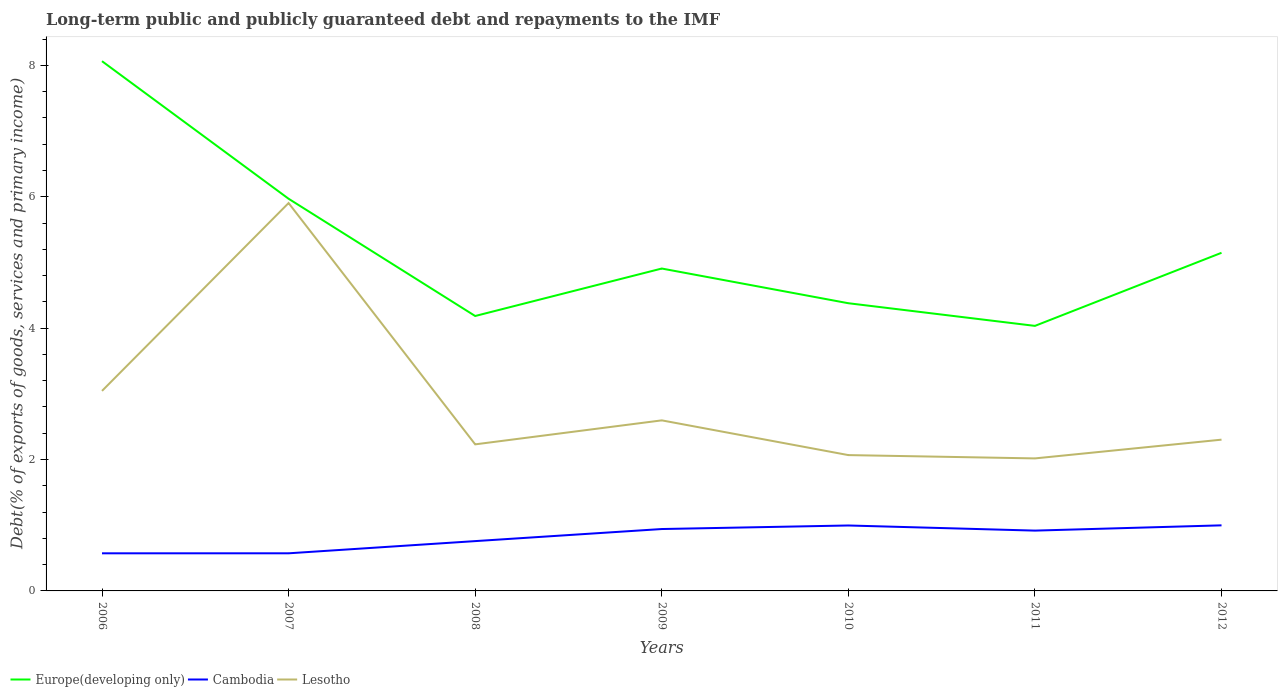Does the line corresponding to Cambodia intersect with the line corresponding to Lesotho?
Ensure brevity in your answer.  No. Is the number of lines equal to the number of legend labels?
Your answer should be compact. Yes. Across all years, what is the maximum debt and repayments in Europe(developing only)?
Give a very brief answer. 4.03. In which year was the debt and repayments in Europe(developing only) maximum?
Your response must be concise. 2011. What is the total debt and repayments in Cambodia in the graph?
Your answer should be very brief. -0.19. What is the difference between the highest and the second highest debt and repayments in Cambodia?
Offer a very short reply. 0.43. Is the debt and repayments in Lesotho strictly greater than the debt and repayments in Europe(developing only) over the years?
Ensure brevity in your answer.  Yes. How many years are there in the graph?
Offer a very short reply. 7. What is the difference between two consecutive major ticks on the Y-axis?
Your answer should be compact. 2. Does the graph contain grids?
Your answer should be very brief. No. Where does the legend appear in the graph?
Ensure brevity in your answer.  Bottom left. How are the legend labels stacked?
Your response must be concise. Horizontal. What is the title of the graph?
Give a very brief answer. Long-term public and publicly guaranteed debt and repayments to the IMF. What is the label or title of the X-axis?
Offer a terse response. Years. What is the label or title of the Y-axis?
Ensure brevity in your answer.  Debt(% of exports of goods, services and primary income). What is the Debt(% of exports of goods, services and primary income) in Europe(developing only) in 2006?
Ensure brevity in your answer.  8.06. What is the Debt(% of exports of goods, services and primary income) of Cambodia in 2006?
Give a very brief answer. 0.57. What is the Debt(% of exports of goods, services and primary income) of Lesotho in 2006?
Offer a terse response. 3.04. What is the Debt(% of exports of goods, services and primary income) in Europe(developing only) in 2007?
Your answer should be very brief. 5.97. What is the Debt(% of exports of goods, services and primary income) of Cambodia in 2007?
Ensure brevity in your answer.  0.57. What is the Debt(% of exports of goods, services and primary income) in Lesotho in 2007?
Your response must be concise. 5.9. What is the Debt(% of exports of goods, services and primary income) in Europe(developing only) in 2008?
Provide a succinct answer. 4.18. What is the Debt(% of exports of goods, services and primary income) in Cambodia in 2008?
Keep it short and to the point. 0.76. What is the Debt(% of exports of goods, services and primary income) in Lesotho in 2008?
Your answer should be compact. 2.23. What is the Debt(% of exports of goods, services and primary income) in Europe(developing only) in 2009?
Give a very brief answer. 4.91. What is the Debt(% of exports of goods, services and primary income) in Cambodia in 2009?
Ensure brevity in your answer.  0.94. What is the Debt(% of exports of goods, services and primary income) of Lesotho in 2009?
Your answer should be very brief. 2.6. What is the Debt(% of exports of goods, services and primary income) in Europe(developing only) in 2010?
Your response must be concise. 4.38. What is the Debt(% of exports of goods, services and primary income) of Cambodia in 2010?
Your answer should be very brief. 1. What is the Debt(% of exports of goods, services and primary income) of Lesotho in 2010?
Your answer should be very brief. 2.07. What is the Debt(% of exports of goods, services and primary income) of Europe(developing only) in 2011?
Your answer should be compact. 4.03. What is the Debt(% of exports of goods, services and primary income) in Cambodia in 2011?
Provide a short and direct response. 0.92. What is the Debt(% of exports of goods, services and primary income) in Lesotho in 2011?
Keep it short and to the point. 2.02. What is the Debt(% of exports of goods, services and primary income) in Europe(developing only) in 2012?
Give a very brief answer. 5.15. What is the Debt(% of exports of goods, services and primary income) of Cambodia in 2012?
Your answer should be very brief. 1. What is the Debt(% of exports of goods, services and primary income) in Lesotho in 2012?
Make the answer very short. 2.3. Across all years, what is the maximum Debt(% of exports of goods, services and primary income) in Europe(developing only)?
Provide a succinct answer. 8.06. Across all years, what is the maximum Debt(% of exports of goods, services and primary income) of Cambodia?
Keep it short and to the point. 1. Across all years, what is the maximum Debt(% of exports of goods, services and primary income) in Lesotho?
Your answer should be very brief. 5.9. Across all years, what is the minimum Debt(% of exports of goods, services and primary income) in Europe(developing only)?
Offer a terse response. 4.03. Across all years, what is the minimum Debt(% of exports of goods, services and primary income) of Cambodia?
Provide a succinct answer. 0.57. Across all years, what is the minimum Debt(% of exports of goods, services and primary income) in Lesotho?
Provide a succinct answer. 2.02. What is the total Debt(% of exports of goods, services and primary income) in Europe(developing only) in the graph?
Your answer should be very brief. 36.69. What is the total Debt(% of exports of goods, services and primary income) in Cambodia in the graph?
Provide a succinct answer. 5.76. What is the total Debt(% of exports of goods, services and primary income) of Lesotho in the graph?
Offer a terse response. 20.16. What is the difference between the Debt(% of exports of goods, services and primary income) of Europe(developing only) in 2006 and that in 2007?
Ensure brevity in your answer.  2.09. What is the difference between the Debt(% of exports of goods, services and primary income) of Cambodia in 2006 and that in 2007?
Make the answer very short. -0. What is the difference between the Debt(% of exports of goods, services and primary income) of Lesotho in 2006 and that in 2007?
Your response must be concise. -2.86. What is the difference between the Debt(% of exports of goods, services and primary income) in Europe(developing only) in 2006 and that in 2008?
Ensure brevity in your answer.  3.88. What is the difference between the Debt(% of exports of goods, services and primary income) in Cambodia in 2006 and that in 2008?
Offer a very short reply. -0.19. What is the difference between the Debt(% of exports of goods, services and primary income) in Lesotho in 2006 and that in 2008?
Offer a terse response. 0.81. What is the difference between the Debt(% of exports of goods, services and primary income) of Europe(developing only) in 2006 and that in 2009?
Your answer should be very brief. 3.16. What is the difference between the Debt(% of exports of goods, services and primary income) of Cambodia in 2006 and that in 2009?
Provide a succinct answer. -0.37. What is the difference between the Debt(% of exports of goods, services and primary income) in Lesotho in 2006 and that in 2009?
Your response must be concise. 0.45. What is the difference between the Debt(% of exports of goods, services and primary income) in Europe(developing only) in 2006 and that in 2010?
Ensure brevity in your answer.  3.68. What is the difference between the Debt(% of exports of goods, services and primary income) of Cambodia in 2006 and that in 2010?
Give a very brief answer. -0.42. What is the difference between the Debt(% of exports of goods, services and primary income) of Lesotho in 2006 and that in 2010?
Ensure brevity in your answer.  0.98. What is the difference between the Debt(% of exports of goods, services and primary income) of Europe(developing only) in 2006 and that in 2011?
Your response must be concise. 4.03. What is the difference between the Debt(% of exports of goods, services and primary income) of Cambodia in 2006 and that in 2011?
Provide a short and direct response. -0.35. What is the difference between the Debt(% of exports of goods, services and primary income) of Lesotho in 2006 and that in 2011?
Offer a very short reply. 1.03. What is the difference between the Debt(% of exports of goods, services and primary income) in Europe(developing only) in 2006 and that in 2012?
Ensure brevity in your answer.  2.92. What is the difference between the Debt(% of exports of goods, services and primary income) of Cambodia in 2006 and that in 2012?
Give a very brief answer. -0.43. What is the difference between the Debt(% of exports of goods, services and primary income) of Lesotho in 2006 and that in 2012?
Ensure brevity in your answer.  0.74. What is the difference between the Debt(% of exports of goods, services and primary income) of Europe(developing only) in 2007 and that in 2008?
Your answer should be compact. 1.78. What is the difference between the Debt(% of exports of goods, services and primary income) in Cambodia in 2007 and that in 2008?
Give a very brief answer. -0.19. What is the difference between the Debt(% of exports of goods, services and primary income) of Lesotho in 2007 and that in 2008?
Give a very brief answer. 3.67. What is the difference between the Debt(% of exports of goods, services and primary income) of Europe(developing only) in 2007 and that in 2009?
Offer a terse response. 1.06. What is the difference between the Debt(% of exports of goods, services and primary income) in Cambodia in 2007 and that in 2009?
Offer a very short reply. -0.37. What is the difference between the Debt(% of exports of goods, services and primary income) in Lesotho in 2007 and that in 2009?
Keep it short and to the point. 3.31. What is the difference between the Debt(% of exports of goods, services and primary income) of Europe(developing only) in 2007 and that in 2010?
Offer a very short reply. 1.59. What is the difference between the Debt(% of exports of goods, services and primary income) in Cambodia in 2007 and that in 2010?
Give a very brief answer. -0.42. What is the difference between the Debt(% of exports of goods, services and primary income) of Lesotho in 2007 and that in 2010?
Make the answer very short. 3.84. What is the difference between the Debt(% of exports of goods, services and primary income) in Europe(developing only) in 2007 and that in 2011?
Provide a succinct answer. 1.94. What is the difference between the Debt(% of exports of goods, services and primary income) in Cambodia in 2007 and that in 2011?
Your answer should be compact. -0.35. What is the difference between the Debt(% of exports of goods, services and primary income) in Lesotho in 2007 and that in 2011?
Offer a terse response. 3.89. What is the difference between the Debt(% of exports of goods, services and primary income) in Europe(developing only) in 2007 and that in 2012?
Your response must be concise. 0.82. What is the difference between the Debt(% of exports of goods, services and primary income) of Cambodia in 2007 and that in 2012?
Your answer should be compact. -0.43. What is the difference between the Debt(% of exports of goods, services and primary income) in Lesotho in 2007 and that in 2012?
Ensure brevity in your answer.  3.6. What is the difference between the Debt(% of exports of goods, services and primary income) of Europe(developing only) in 2008 and that in 2009?
Ensure brevity in your answer.  -0.72. What is the difference between the Debt(% of exports of goods, services and primary income) in Cambodia in 2008 and that in 2009?
Keep it short and to the point. -0.18. What is the difference between the Debt(% of exports of goods, services and primary income) of Lesotho in 2008 and that in 2009?
Your answer should be compact. -0.37. What is the difference between the Debt(% of exports of goods, services and primary income) of Europe(developing only) in 2008 and that in 2010?
Your answer should be compact. -0.19. What is the difference between the Debt(% of exports of goods, services and primary income) in Cambodia in 2008 and that in 2010?
Your answer should be very brief. -0.24. What is the difference between the Debt(% of exports of goods, services and primary income) of Lesotho in 2008 and that in 2010?
Make the answer very short. 0.16. What is the difference between the Debt(% of exports of goods, services and primary income) of Europe(developing only) in 2008 and that in 2011?
Your answer should be compact. 0.15. What is the difference between the Debt(% of exports of goods, services and primary income) in Cambodia in 2008 and that in 2011?
Ensure brevity in your answer.  -0.16. What is the difference between the Debt(% of exports of goods, services and primary income) in Lesotho in 2008 and that in 2011?
Provide a short and direct response. 0.21. What is the difference between the Debt(% of exports of goods, services and primary income) of Europe(developing only) in 2008 and that in 2012?
Give a very brief answer. -0.96. What is the difference between the Debt(% of exports of goods, services and primary income) in Cambodia in 2008 and that in 2012?
Your answer should be compact. -0.24. What is the difference between the Debt(% of exports of goods, services and primary income) of Lesotho in 2008 and that in 2012?
Your response must be concise. -0.07. What is the difference between the Debt(% of exports of goods, services and primary income) of Europe(developing only) in 2009 and that in 2010?
Keep it short and to the point. 0.53. What is the difference between the Debt(% of exports of goods, services and primary income) in Cambodia in 2009 and that in 2010?
Your response must be concise. -0.05. What is the difference between the Debt(% of exports of goods, services and primary income) in Lesotho in 2009 and that in 2010?
Make the answer very short. 0.53. What is the difference between the Debt(% of exports of goods, services and primary income) in Europe(developing only) in 2009 and that in 2011?
Provide a short and direct response. 0.87. What is the difference between the Debt(% of exports of goods, services and primary income) in Cambodia in 2009 and that in 2011?
Offer a very short reply. 0.02. What is the difference between the Debt(% of exports of goods, services and primary income) of Lesotho in 2009 and that in 2011?
Provide a succinct answer. 0.58. What is the difference between the Debt(% of exports of goods, services and primary income) in Europe(developing only) in 2009 and that in 2012?
Provide a short and direct response. -0.24. What is the difference between the Debt(% of exports of goods, services and primary income) of Cambodia in 2009 and that in 2012?
Your answer should be compact. -0.06. What is the difference between the Debt(% of exports of goods, services and primary income) in Lesotho in 2009 and that in 2012?
Make the answer very short. 0.29. What is the difference between the Debt(% of exports of goods, services and primary income) of Europe(developing only) in 2010 and that in 2011?
Offer a terse response. 0.34. What is the difference between the Debt(% of exports of goods, services and primary income) in Cambodia in 2010 and that in 2011?
Your answer should be compact. 0.08. What is the difference between the Debt(% of exports of goods, services and primary income) in Lesotho in 2010 and that in 2011?
Offer a very short reply. 0.05. What is the difference between the Debt(% of exports of goods, services and primary income) in Europe(developing only) in 2010 and that in 2012?
Offer a very short reply. -0.77. What is the difference between the Debt(% of exports of goods, services and primary income) of Cambodia in 2010 and that in 2012?
Make the answer very short. -0. What is the difference between the Debt(% of exports of goods, services and primary income) of Lesotho in 2010 and that in 2012?
Make the answer very short. -0.23. What is the difference between the Debt(% of exports of goods, services and primary income) of Europe(developing only) in 2011 and that in 2012?
Provide a succinct answer. -1.11. What is the difference between the Debt(% of exports of goods, services and primary income) in Cambodia in 2011 and that in 2012?
Ensure brevity in your answer.  -0.08. What is the difference between the Debt(% of exports of goods, services and primary income) of Lesotho in 2011 and that in 2012?
Your answer should be compact. -0.29. What is the difference between the Debt(% of exports of goods, services and primary income) of Europe(developing only) in 2006 and the Debt(% of exports of goods, services and primary income) of Cambodia in 2007?
Provide a short and direct response. 7.49. What is the difference between the Debt(% of exports of goods, services and primary income) of Europe(developing only) in 2006 and the Debt(% of exports of goods, services and primary income) of Lesotho in 2007?
Provide a succinct answer. 2.16. What is the difference between the Debt(% of exports of goods, services and primary income) of Cambodia in 2006 and the Debt(% of exports of goods, services and primary income) of Lesotho in 2007?
Your response must be concise. -5.33. What is the difference between the Debt(% of exports of goods, services and primary income) of Europe(developing only) in 2006 and the Debt(% of exports of goods, services and primary income) of Cambodia in 2008?
Ensure brevity in your answer.  7.31. What is the difference between the Debt(% of exports of goods, services and primary income) of Europe(developing only) in 2006 and the Debt(% of exports of goods, services and primary income) of Lesotho in 2008?
Keep it short and to the point. 5.83. What is the difference between the Debt(% of exports of goods, services and primary income) in Cambodia in 2006 and the Debt(% of exports of goods, services and primary income) in Lesotho in 2008?
Ensure brevity in your answer.  -1.66. What is the difference between the Debt(% of exports of goods, services and primary income) of Europe(developing only) in 2006 and the Debt(% of exports of goods, services and primary income) of Cambodia in 2009?
Offer a very short reply. 7.12. What is the difference between the Debt(% of exports of goods, services and primary income) in Europe(developing only) in 2006 and the Debt(% of exports of goods, services and primary income) in Lesotho in 2009?
Your response must be concise. 5.47. What is the difference between the Debt(% of exports of goods, services and primary income) of Cambodia in 2006 and the Debt(% of exports of goods, services and primary income) of Lesotho in 2009?
Your answer should be compact. -2.02. What is the difference between the Debt(% of exports of goods, services and primary income) in Europe(developing only) in 2006 and the Debt(% of exports of goods, services and primary income) in Cambodia in 2010?
Ensure brevity in your answer.  7.07. What is the difference between the Debt(% of exports of goods, services and primary income) of Europe(developing only) in 2006 and the Debt(% of exports of goods, services and primary income) of Lesotho in 2010?
Ensure brevity in your answer.  6. What is the difference between the Debt(% of exports of goods, services and primary income) of Cambodia in 2006 and the Debt(% of exports of goods, services and primary income) of Lesotho in 2010?
Make the answer very short. -1.5. What is the difference between the Debt(% of exports of goods, services and primary income) in Europe(developing only) in 2006 and the Debt(% of exports of goods, services and primary income) in Cambodia in 2011?
Your answer should be compact. 7.15. What is the difference between the Debt(% of exports of goods, services and primary income) in Europe(developing only) in 2006 and the Debt(% of exports of goods, services and primary income) in Lesotho in 2011?
Make the answer very short. 6.05. What is the difference between the Debt(% of exports of goods, services and primary income) of Cambodia in 2006 and the Debt(% of exports of goods, services and primary income) of Lesotho in 2011?
Keep it short and to the point. -1.44. What is the difference between the Debt(% of exports of goods, services and primary income) of Europe(developing only) in 2006 and the Debt(% of exports of goods, services and primary income) of Cambodia in 2012?
Give a very brief answer. 7.07. What is the difference between the Debt(% of exports of goods, services and primary income) of Europe(developing only) in 2006 and the Debt(% of exports of goods, services and primary income) of Lesotho in 2012?
Ensure brevity in your answer.  5.76. What is the difference between the Debt(% of exports of goods, services and primary income) in Cambodia in 2006 and the Debt(% of exports of goods, services and primary income) in Lesotho in 2012?
Make the answer very short. -1.73. What is the difference between the Debt(% of exports of goods, services and primary income) in Europe(developing only) in 2007 and the Debt(% of exports of goods, services and primary income) in Cambodia in 2008?
Ensure brevity in your answer.  5.21. What is the difference between the Debt(% of exports of goods, services and primary income) of Europe(developing only) in 2007 and the Debt(% of exports of goods, services and primary income) of Lesotho in 2008?
Offer a terse response. 3.74. What is the difference between the Debt(% of exports of goods, services and primary income) in Cambodia in 2007 and the Debt(% of exports of goods, services and primary income) in Lesotho in 2008?
Make the answer very short. -1.66. What is the difference between the Debt(% of exports of goods, services and primary income) of Europe(developing only) in 2007 and the Debt(% of exports of goods, services and primary income) of Cambodia in 2009?
Ensure brevity in your answer.  5.03. What is the difference between the Debt(% of exports of goods, services and primary income) of Europe(developing only) in 2007 and the Debt(% of exports of goods, services and primary income) of Lesotho in 2009?
Offer a terse response. 3.37. What is the difference between the Debt(% of exports of goods, services and primary income) of Cambodia in 2007 and the Debt(% of exports of goods, services and primary income) of Lesotho in 2009?
Make the answer very short. -2.02. What is the difference between the Debt(% of exports of goods, services and primary income) of Europe(developing only) in 2007 and the Debt(% of exports of goods, services and primary income) of Cambodia in 2010?
Keep it short and to the point. 4.97. What is the difference between the Debt(% of exports of goods, services and primary income) in Europe(developing only) in 2007 and the Debt(% of exports of goods, services and primary income) in Lesotho in 2010?
Offer a very short reply. 3.9. What is the difference between the Debt(% of exports of goods, services and primary income) of Cambodia in 2007 and the Debt(% of exports of goods, services and primary income) of Lesotho in 2010?
Keep it short and to the point. -1.5. What is the difference between the Debt(% of exports of goods, services and primary income) of Europe(developing only) in 2007 and the Debt(% of exports of goods, services and primary income) of Cambodia in 2011?
Ensure brevity in your answer.  5.05. What is the difference between the Debt(% of exports of goods, services and primary income) of Europe(developing only) in 2007 and the Debt(% of exports of goods, services and primary income) of Lesotho in 2011?
Provide a short and direct response. 3.95. What is the difference between the Debt(% of exports of goods, services and primary income) in Cambodia in 2007 and the Debt(% of exports of goods, services and primary income) in Lesotho in 2011?
Provide a short and direct response. -1.44. What is the difference between the Debt(% of exports of goods, services and primary income) of Europe(developing only) in 2007 and the Debt(% of exports of goods, services and primary income) of Cambodia in 2012?
Provide a succinct answer. 4.97. What is the difference between the Debt(% of exports of goods, services and primary income) in Europe(developing only) in 2007 and the Debt(% of exports of goods, services and primary income) in Lesotho in 2012?
Offer a terse response. 3.67. What is the difference between the Debt(% of exports of goods, services and primary income) of Cambodia in 2007 and the Debt(% of exports of goods, services and primary income) of Lesotho in 2012?
Give a very brief answer. -1.73. What is the difference between the Debt(% of exports of goods, services and primary income) of Europe(developing only) in 2008 and the Debt(% of exports of goods, services and primary income) of Cambodia in 2009?
Give a very brief answer. 3.24. What is the difference between the Debt(% of exports of goods, services and primary income) of Europe(developing only) in 2008 and the Debt(% of exports of goods, services and primary income) of Lesotho in 2009?
Your response must be concise. 1.59. What is the difference between the Debt(% of exports of goods, services and primary income) in Cambodia in 2008 and the Debt(% of exports of goods, services and primary income) in Lesotho in 2009?
Your answer should be very brief. -1.84. What is the difference between the Debt(% of exports of goods, services and primary income) in Europe(developing only) in 2008 and the Debt(% of exports of goods, services and primary income) in Cambodia in 2010?
Your answer should be very brief. 3.19. What is the difference between the Debt(% of exports of goods, services and primary income) in Europe(developing only) in 2008 and the Debt(% of exports of goods, services and primary income) in Lesotho in 2010?
Offer a terse response. 2.12. What is the difference between the Debt(% of exports of goods, services and primary income) of Cambodia in 2008 and the Debt(% of exports of goods, services and primary income) of Lesotho in 2010?
Give a very brief answer. -1.31. What is the difference between the Debt(% of exports of goods, services and primary income) of Europe(developing only) in 2008 and the Debt(% of exports of goods, services and primary income) of Cambodia in 2011?
Keep it short and to the point. 3.27. What is the difference between the Debt(% of exports of goods, services and primary income) of Europe(developing only) in 2008 and the Debt(% of exports of goods, services and primary income) of Lesotho in 2011?
Ensure brevity in your answer.  2.17. What is the difference between the Debt(% of exports of goods, services and primary income) of Cambodia in 2008 and the Debt(% of exports of goods, services and primary income) of Lesotho in 2011?
Keep it short and to the point. -1.26. What is the difference between the Debt(% of exports of goods, services and primary income) of Europe(developing only) in 2008 and the Debt(% of exports of goods, services and primary income) of Cambodia in 2012?
Provide a succinct answer. 3.19. What is the difference between the Debt(% of exports of goods, services and primary income) of Europe(developing only) in 2008 and the Debt(% of exports of goods, services and primary income) of Lesotho in 2012?
Your response must be concise. 1.88. What is the difference between the Debt(% of exports of goods, services and primary income) in Cambodia in 2008 and the Debt(% of exports of goods, services and primary income) in Lesotho in 2012?
Keep it short and to the point. -1.54. What is the difference between the Debt(% of exports of goods, services and primary income) in Europe(developing only) in 2009 and the Debt(% of exports of goods, services and primary income) in Cambodia in 2010?
Keep it short and to the point. 3.91. What is the difference between the Debt(% of exports of goods, services and primary income) of Europe(developing only) in 2009 and the Debt(% of exports of goods, services and primary income) of Lesotho in 2010?
Offer a very short reply. 2.84. What is the difference between the Debt(% of exports of goods, services and primary income) of Cambodia in 2009 and the Debt(% of exports of goods, services and primary income) of Lesotho in 2010?
Make the answer very short. -1.13. What is the difference between the Debt(% of exports of goods, services and primary income) in Europe(developing only) in 2009 and the Debt(% of exports of goods, services and primary income) in Cambodia in 2011?
Your answer should be compact. 3.99. What is the difference between the Debt(% of exports of goods, services and primary income) in Europe(developing only) in 2009 and the Debt(% of exports of goods, services and primary income) in Lesotho in 2011?
Your answer should be very brief. 2.89. What is the difference between the Debt(% of exports of goods, services and primary income) in Cambodia in 2009 and the Debt(% of exports of goods, services and primary income) in Lesotho in 2011?
Give a very brief answer. -1.08. What is the difference between the Debt(% of exports of goods, services and primary income) in Europe(developing only) in 2009 and the Debt(% of exports of goods, services and primary income) in Cambodia in 2012?
Offer a terse response. 3.91. What is the difference between the Debt(% of exports of goods, services and primary income) of Europe(developing only) in 2009 and the Debt(% of exports of goods, services and primary income) of Lesotho in 2012?
Offer a terse response. 2.6. What is the difference between the Debt(% of exports of goods, services and primary income) in Cambodia in 2009 and the Debt(% of exports of goods, services and primary income) in Lesotho in 2012?
Ensure brevity in your answer.  -1.36. What is the difference between the Debt(% of exports of goods, services and primary income) of Europe(developing only) in 2010 and the Debt(% of exports of goods, services and primary income) of Cambodia in 2011?
Offer a terse response. 3.46. What is the difference between the Debt(% of exports of goods, services and primary income) in Europe(developing only) in 2010 and the Debt(% of exports of goods, services and primary income) in Lesotho in 2011?
Your answer should be compact. 2.36. What is the difference between the Debt(% of exports of goods, services and primary income) of Cambodia in 2010 and the Debt(% of exports of goods, services and primary income) of Lesotho in 2011?
Give a very brief answer. -1.02. What is the difference between the Debt(% of exports of goods, services and primary income) of Europe(developing only) in 2010 and the Debt(% of exports of goods, services and primary income) of Cambodia in 2012?
Make the answer very short. 3.38. What is the difference between the Debt(% of exports of goods, services and primary income) of Europe(developing only) in 2010 and the Debt(% of exports of goods, services and primary income) of Lesotho in 2012?
Provide a succinct answer. 2.08. What is the difference between the Debt(% of exports of goods, services and primary income) in Cambodia in 2010 and the Debt(% of exports of goods, services and primary income) in Lesotho in 2012?
Your response must be concise. -1.31. What is the difference between the Debt(% of exports of goods, services and primary income) in Europe(developing only) in 2011 and the Debt(% of exports of goods, services and primary income) in Cambodia in 2012?
Your answer should be compact. 3.04. What is the difference between the Debt(% of exports of goods, services and primary income) in Europe(developing only) in 2011 and the Debt(% of exports of goods, services and primary income) in Lesotho in 2012?
Your response must be concise. 1.73. What is the difference between the Debt(% of exports of goods, services and primary income) of Cambodia in 2011 and the Debt(% of exports of goods, services and primary income) of Lesotho in 2012?
Offer a terse response. -1.38. What is the average Debt(% of exports of goods, services and primary income) in Europe(developing only) per year?
Provide a succinct answer. 5.24. What is the average Debt(% of exports of goods, services and primary income) of Cambodia per year?
Offer a terse response. 0.82. What is the average Debt(% of exports of goods, services and primary income) in Lesotho per year?
Your answer should be compact. 2.88. In the year 2006, what is the difference between the Debt(% of exports of goods, services and primary income) of Europe(developing only) and Debt(% of exports of goods, services and primary income) of Cambodia?
Keep it short and to the point. 7.49. In the year 2006, what is the difference between the Debt(% of exports of goods, services and primary income) of Europe(developing only) and Debt(% of exports of goods, services and primary income) of Lesotho?
Give a very brief answer. 5.02. In the year 2006, what is the difference between the Debt(% of exports of goods, services and primary income) of Cambodia and Debt(% of exports of goods, services and primary income) of Lesotho?
Keep it short and to the point. -2.47. In the year 2007, what is the difference between the Debt(% of exports of goods, services and primary income) in Europe(developing only) and Debt(% of exports of goods, services and primary income) in Cambodia?
Offer a terse response. 5.4. In the year 2007, what is the difference between the Debt(% of exports of goods, services and primary income) of Europe(developing only) and Debt(% of exports of goods, services and primary income) of Lesotho?
Offer a very short reply. 0.07. In the year 2007, what is the difference between the Debt(% of exports of goods, services and primary income) of Cambodia and Debt(% of exports of goods, services and primary income) of Lesotho?
Offer a very short reply. -5.33. In the year 2008, what is the difference between the Debt(% of exports of goods, services and primary income) of Europe(developing only) and Debt(% of exports of goods, services and primary income) of Cambodia?
Your answer should be very brief. 3.43. In the year 2008, what is the difference between the Debt(% of exports of goods, services and primary income) of Europe(developing only) and Debt(% of exports of goods, services and primary income) of Lesotho?
Provide a short and direct response. 1.95. In the year 2008, what is the difference between the Debt(% of exports of goods, services and primary income) of Cambodia and Debt(% of exports of goods, services and primary income) of Lesotho?
Keep it short and to the point. -1.47. In the year 2009, what is the difference between the Debt(% of exports of goods, services and primary income) of Europe(developing only) and Debt(% of exports of goods, services and primary income) of Cambodia?
Offer a very short reply. 3.97. In the year 2009, what is the difference between the Debt(% of exports of goods, services and primary income) of Europe(developing only) and Debt(% of exports of goods, services and primary income) of Lesotho?
Provide a short and direct response. 2.31. In the year 2009, what is the difference between the Debt(% of exports of goods, services and primary income) of Cambodia and Debt(% of exports of goods, services and primary income) of Lesotho?
Provide a succinct answer. -1.65. In the year 2010, what is the difference between the Debt(% of exports of goods, services and primary income) of Europe(developing only) and Debt(% of exports of goods, services and primary income) of Cambodia?
Offer a terse response. 3.38. In the year 2010, what is the difference between the Debt(% of exports of goods, services and primary income) of Europe(developing only) and Debt(% of exports of goods, services and primary income) of Lesotho?
Provide a short and direct response. 2.31. In the year 2010, what is the difference between the Debt(% of exports of goods, services and primary income) in Cambodia and Debt(% of exports of goods, services and primary income) in Lesotho?
Your answer should be very brief. -1.07. In the year 2011, what is the difference between the Debt(% of exports of goods, services and primary income) in Europe(developing only) and Debt(% of exports of goods, services and primary income) in Cambodia?
Keep it short and to the point. 3.12. In the year 2011, what is the difference between the Debt(% of exports of goods, services and primary income) of Europe(developing only) and Debt(% of exports of goods, services and primary income) of Lesotho?
Provide a succinct answer. 2.02. In the year 2011, what is the difference between the Debt(% of exports of goods, services and primary income) of Cambodia and Debt(% of exports of goods, services and primary income) of Lesotho?
Offer a terse response. -1.1. In the year 2012, what is the difference between the Debt(% of exports of goods, services and primary income) of Europe(developing only) and Debt(% of exports of goods, services and primary income) of Cambodia?
Offer a very short reply. 4.15. In the year 2012, what is the difference between the Debt(% of exports of goods, services and primary income) of Europe(developing only) and Debt(% of exports of goods, services and primary income) of Lesotho?
Your response must be concise. 2.84. In the year 2012, what is the difference between the Debt(% of exports of goods, services and primary income) in Cambodia and Debt(% of exports of goods, services and primary income) in Lesotho?
Your answer should be very brief. -1.3. What is the ratio of the Debt(% of exports of goods, services and primary income) of Europe(developing only) in 2006 to that in 2007?
Keep it short and to the point. 1.35. What is the ratio of the Debt(% of exports of goods, services and primary income) of Cambodia in 2006 to that in 2007?
Give a very brief answer. 1. What is the ratio of the Debt(% of exports of goods, services and primary income) in Lesotho in 2006 to that in 2007?
Provide a succinct answer. 0.52. What is the ratio of the Debt(% of exports of goods, services and primary income) in Europe(developing only) in 2006 to that in 2008?
Offer a terse response. 1.93. What is the ratio of the Debt(% of exports of goods, services and primary income) in Cambodia in 2006 to that in 2008?
Your answer should be very brief. 0.76. What is the ratio of the Debt(% of exports of goods, services and primary income) of Lesotho in 2006 to that in 2008?
Make the answer very short. 1.36. What is the ratio of the Debt(% of exports of goods, services and primary income) in Europe(developing only) in 2006 to that in 2009?
Your answer should be compact. 1.64. What is the ratio of the Debt(% of exports of goods, services and primary income) of Cambodia in 2006 to that in 2009?
Ensure brevity in your answer.  0.61. What is the ratio of the Debt(% of exports of goods, services and primary income) in Lesotho in 2006 to that in 2009?
Offer a terse response. 1.17. What is the ratio of the Debt(% of exports of goods, services and primary income) of Europe(developing only) in 2006 to that in 2010?
Offer a very short reply. 1.84. What is the ratio of the Debt(% of exports of goods, services and primary income) of Cambodia in 2006 to that in 2010?
Offer a very short reply. 0.57. What is the ratio of the Debt(% of exports of goods, services and primary income) in Lesotho in 2006 to that in 2010?
Offer a terse response. 1.47. What is the ratio of the Debt(% of exports of goods, services and primary income) in Europe(developing only) in 2006 to that in 2011?
Keep it short and to the point. 2. What is the ratio of the Debt(% of exports of goods, services and primary income) of Cambodia in 2006 to that in 2011?
Make the answer very short. 0.62. What is the ratio of the Debt(% of exports of goods, services and primary income) in Lesotho in 2006 to that in 2011?
Your answer should be compact. 1.51. What is the ratio of the Debt(% of exports of goods, services and primary income) of Europe(developing only) in 2006 to that in 2012?
Your answer should be compact. 1.57. What is the ratio of the Debt(% of exports of goods, services and primary income) of Cambodia in 2006 to that in 2012?
Provide a short and direct response. 0.57. What is the ratio of the Debt(% of exports of goods, services and primary income) in Lesotho in 2006 to that in 2012?
Offer a terse response. 1.32. What is the ratio of the Debt(% of exports of goods, services and primary income) of Europe(developing only) in 2007 to that in 2008?
Your answer should be very brief. 1.43. What is the ratio of the Debt(% of exports of goods, services and primary income) in Cambodia in 2007 to that in 2008?
Your answer should be very brief. 0.76. What is the ratio of the Debt(% of exports of goods, services and primary income) of Lesotho in 2007 to that in 2008?
Your response must be concise. 2.65. What is the ratio of the Debt(% of exports of goods, services and primary income) of Europe(developing only) in 2007 to that in 2009?
Offer a terse response. 1.22. What is the ratio of the Debt(% of exports of goods, services and primary income) in Cambodia in 2007 to that in 2009?
Your answer should be very brief. 0.61. What is the ratio of the Debt(% of exports of goods, services and primary income) in Lesotho in 2007 to that in 2009?
Ensure brevity in your answer.  2.27. What is the ratio of the Debt(% of exports of goods, services and primary income) of Europe(developing only) in 2007 to that in 2010?
Provide a succinct answer. 1.36. What is the ratio of the Debt(% of exports of goods, services and primary income) of Cambodia in 2007 to that in 2010?
Provide a succinct answer. 0.57. What is the ratio of the Debt(% of exports of goods, services and primary income) in Lesotho in 2007 to that in 2010?
Keep it short and to the point. 2.86. What is the ratio of the Debt(% of exports of goods, services and primary income) of Europe(developing only) in 2007 to that in 2011?
Your answer should be compact. 1.48. What is the ratio of the Debt(% of exports of goods, services and primary income) in Cambodia in 2007 to that in 2011?
Your answer should be compact. 0.62. What is the ratio of the Debt(% of exports of goods, services and primary income) of Lesotho in 2007 to that in 2011?
Offer a very short reply. 2.93. What is the ratio of the Debt(% of exports of goods, services and primary income) in Europe(developing only) in 2007 to that in 2012?
Your answer should be compact. 1.16. What is the ratio of the Debt(% of exports of goods, services and primary income) in Cambodia in 2007 to that in 2012?
Your response must be concise. 0.57. What is the ratio of the Debt(% of exports of goods, services and primary income) of Lesotho in 2007 to that in 2012?
Your response must be concise. 2.56. What is the ratio of the Debt(% of exports of goods, services and primary income) of Europe(developing only) in 2008 to that in 2009?
Keep it short and to the point. 0.85. What is the ratio of the Debt(% of exports of goods, services and primary income) of Cambodia in 2008 to that in 2009?
Make the answer very short. 0.8. What is the ratio of the Debt(% of exports of goods, services and primary income) of Lesotho in 2008 to that in 2009?
Provide a succinct answer. 0.86. What is the ratio of the Debt(% of exports of goods, services and primary income) in Europe(developing only) in 2008 to that in 2010?
Provide a short and direct response. 0.96. What is the ratio of the Debt(% of exports of goods, services and primary income) in Cambodia in 2008 to that in 2010?
Offer a terse response. 0.76. What is the ratio of the Debt(% of exports of goods, services and primary income) of Lesotho in 2008 to that in 2010?
Ensure brevity in your answer.  1.08. What is the ratio of the Debt(% of exports of goods, services and primary income) of Europe(developing only) in 2008 to that in 2011?
Keep it short and to the point. 1.04. What is the ratio of the Debt(% of exports of goods, services and primary income) in Cambodia in 2008 to that in 2011?
Offer a very short reply. 0.83. What is the ratio of the Debt(% of exports of goods, services and primary income) of Lesotho in 2008 to that in 2011?
Provide a succinct answer. 1.11. What is the ratio of the Debt(% of exports of goods, services and primary income) of Europe(developing only) in 2008 to that in 2012?
Offer a very short reply. 0.81. What is the ratio of the Debt(% of exports of goods, services and primary income) in Cambodia in 2008 to that in 2012?
Ensure brevity in your answer.  0.76. What is the ratio of the Debt(% of exports of goods, services and primary income) in Lesotho in 2008 to that in 2012?
Provide a succinct answer. 0.97. What is the ratio of the Debt(% of exports of goods, services and primary income) in Europe(developing only) in 2009 to that in 2010?
Provide a succinct answer. 1.12. What is the ratio of the Debt(% of exports of goods, services and primary income) of Cambodia in 2009 to that in 2010?
Ensure brevity in your answer.  0.95. What is the ratio of the Debt(% of exports of goods, services and primary income) in Lesotho in 2009 to that in 2010?
Offer a very short reply. 1.26. What is the ratio of the Debt(% of exports of goods, services and primary income) of Europe(developing only) in 2009 to that in 2011?
Provide a short and direct response. 1.22. What is the ratio of the Debt(% of exports of goods, services and primary income) in Cambodia in 2009 to that in 2011?
Provide a succinct answer. 1.03. What is the ratio of the Debt(% of exports of goods, services and primary income) of Lesotho in 2009 to that in 2011?
Offer a terse response. 1.29. What is the ratio of the Debt(% of exports of goods, services and primary income) of Europe(developing only) in 2009 to that in 2012?
Give a very brief answer. 0.95. What is the ratio of the Debt(% of exports of goods, services and primary income) in Cambodia in 2009 to that in 2012?
Ensure brevity in your answer.  0.94. What is the ratio of the Debt(% of exports of goods, services and primary income) in Lesotho in 2009 to that in 2012?
Your answer should be very brief. 1.13. What is the ratio of the Debt(% of exports of goods, services and primary income) in Europe(developing only) in 2010 to that in 2011?
Provide a succinct answer. 1.09. What is the ratio of the Debt(% of exports of goods, services and primary income) of Cambodia in 2010 to that in 2011?
Your answer should be very brief. 1.09. What is the ratio of the Debt(% of exports of goods, services and primary income) of Europe(developing only) in 2010 to that in 2012?
Your response must be concise. 0.85. What is the ratio of the Debt(% of exports of goods, services and primary income) in Cambodia in 2010 to that in 2012?
Make the answer very short. 1. What is the ratio of the Debt(% of exports of goods, services and primary income) of Lesotho in 2010 to that in 2012?
Your answer should be compact. 0.9. What is the ratio of the Debt(% of exports of goods, services and primary income) of Europe(developing only) in 2011 to that in 2012?
Provide a succinct answer. 0.78. What is the ratio of the Debt(% of exports of goods, services and primary income) of Cambodia in 2011 to that in 2012?
Give a very brief answer. 0.92. What is the ratio of the Debt(% of exports of goods, services and primary income) of Lesotho in 2011 to that in 2012?
Make the answer very short. 0.88. What is the difference between the highest and the second highest Debt(% of exports of goods, services and primary income) of Europe(developing only)?
Ensure brevity in your answer.  2.09. What is the difference between the highest and the second highest Debt(% of exports of goods, services and primary income) of Cambodia?
Give a very brief answer. 0. What is the difference between the highest and the second highest Debt(% of exports of goods, services and primary income) of Lesotho?
Your response must be concise. 2.86. What is the difference between the highest and the lowest Debt(% of exports of goods, services and primary income) of Europe(developing only)?
Offer a terse response. 4.03. What is the difference between the highest and the lowest Debt(% of exports of goods, services and primary income) in Cambodia?
Give a very brief answer. 0.43. What is the difference between the highest and the lowest Debt(% of exports of goods, services and primary income) in Lesotho?
Your answer should be very brief. 3.89. 